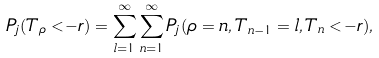Convert formula to latex. <formula><loc_0><loc_0><loc_500><loc_500>P _ { j } ( T _ { \rho } < - r ) = \sum _ { l = 1 } ^ { \infty } \sum _ { n = 1 } ^ { \infty } P _ { j } ( \rho = n , T _ { n - 1 } = l , T _ { n } < - r ) ,</formula> 